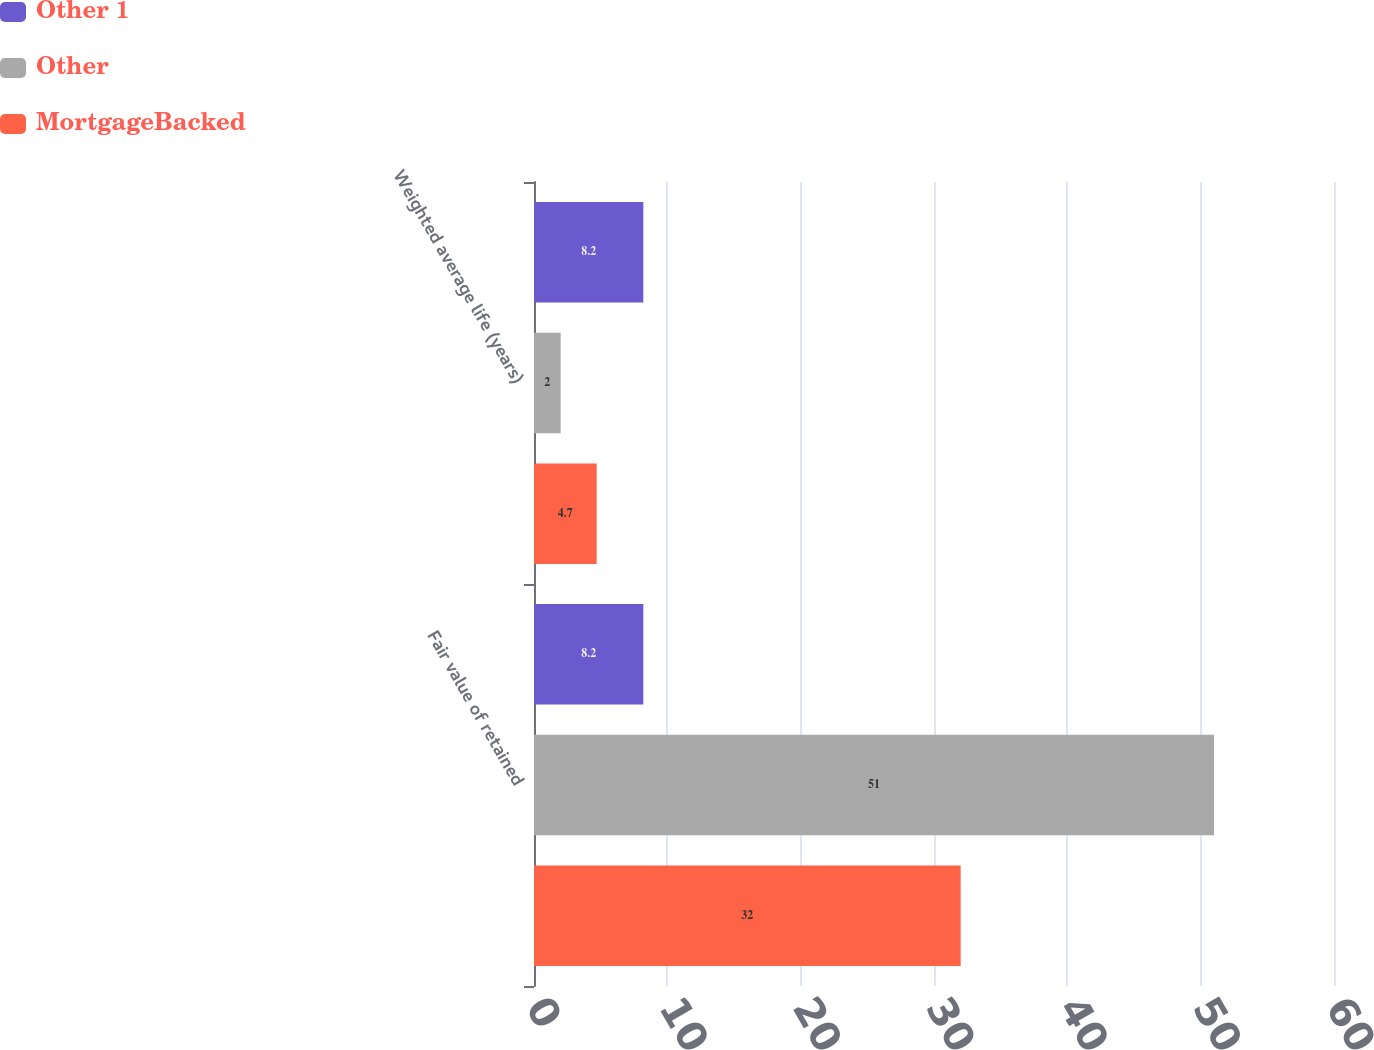Convert chart. <chart><loc_0><loc_0><loc_500><loc_500><stacked_bar_chart><ecel><fcel>Fair value of retained<fcel>Weighted average life (years)<nl><fcel>Other 1<fcel>8.2<fcel>8.2<nl><fcel>Other<fcel>51<fcel>2<nl><fcel>MortgageBacked<fcel>32<fcel>4.7<nl></chart> 